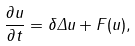<formula> <loc_0><loc_0><loc_500><loc_500>\frac { \partial u } { \partial t } = \delta \Delta u + F ( u ) ,</formula> 